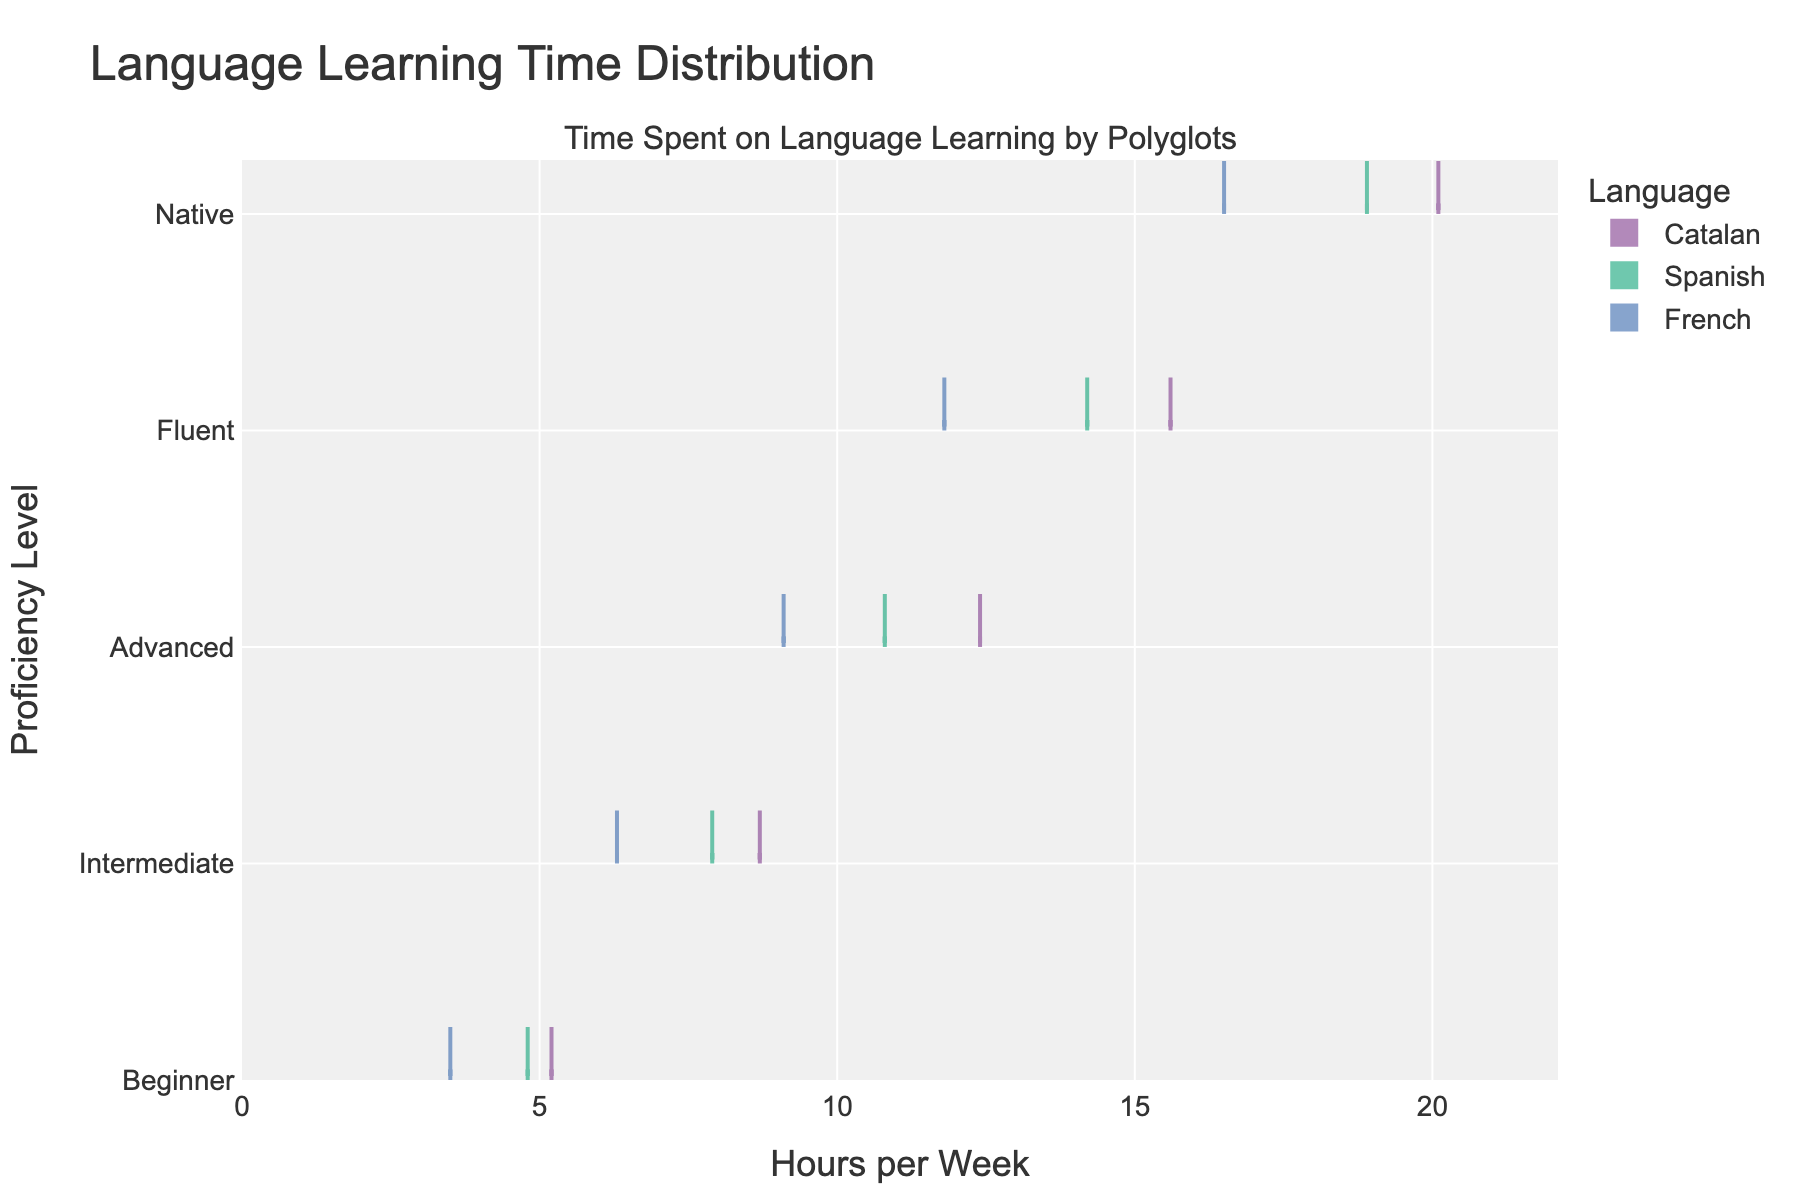What is the title of the plot? The title is displayed at the top of the plot and reads "Language Learning Time Distribution".
Answer: Language Learning Time Distribution Which language shows the highest number of hours for the 'Native' proficiency level? By observing the 'Native' proficiency level bands, Catalan has the highest number of hours (20.1) per week.
Answer: Catalan At which proficiency level does the average time spent learning Catalan surpass 10 hours per week? Review the midpoints of the distribution for each proficiency level for Catalan. 'Advanced' proficiency level shows an average above 10 hours (12.4 hours per week).
Answer: Advanced How does the time spent on learning Spanish differ between 'Intermediate' and 'Advanced' levels? Observe the distribution bands for Spanish. The 'Intermediate' level is at approximately 7.9 hours, and the 'Advanced' level is approximately 10.8 hours. The difference is 10.8 - 7.9 = 2.9 hours.
Answer: 2.9 hours Which proficiency level has the widest spread for French in terms of hours spent per week? Compare the span of horizontal distributions for each proficiency level for French. The 'Native' level appears to have the widest spread, ranging from lower to higher hours spent.
Answer: Native Do fluent users spend more time learning Catalan or French? By how much? Compare the hours per week for 'Fluent' users of Catalan and French. Catalan is at 15.6 hours, and French is at 11.8 hours. The difference is 15.6 - 11.8 = 3.8 hours.
Answer: Catalan, by 3.8 hours What is the range of hours spent per week for the 'Beginner' proficiency level across all languages? Review the minimum and maximum hours per week for 'Beginner' level across Catalan (5.2), Spanish (4.8), and French (3.5). The range is from 3.5 to 5.2 hours.
Answer: 3.5 to 5.2 hours Which language has the smallest increase in hours from 'Intermediate' to 'Advanced' levels? Calculate the difference between 'Intermediate' and 'Advanced' for each language. Catalan: 12.4 - 8.7 = 3.7 hours, Spanish: 10.8 - 7.9 = 2.9 hours, French: 9.1 - 6.3 = 2.8 hours. French has the smallest increase.
Answer: French What is the overall trend in hours spent learning languages as proficiency levels increase? Observe the progression from 'Beginner' to 'Native' levels for all languages. There is a general increase in hours spent per week as proficiency levels improve.
Answer: Increase 